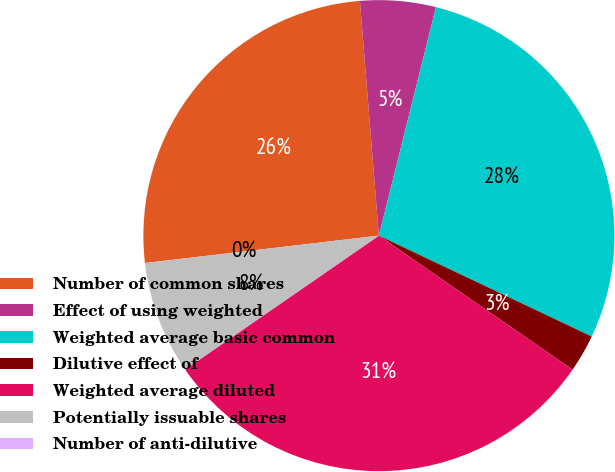<chart> <loc_0><loc_0><loc_500><loc_500><pie_chart><fcel>Number of common shares<fcel>Effect of using weighted<fcel>Weighted average basic common<fcel>Dilutive effect of<fcel>Weighted average diluted<fcel>Potentially issuable shares<fcel>Number of anti-dilutive<nl><fcel>25.57%<fcel>5.18%<fcel>28.15%<fcel>2.59%<fcel>30.74%<fcel>7.76%<fcel>0.01%<nl></chart> 